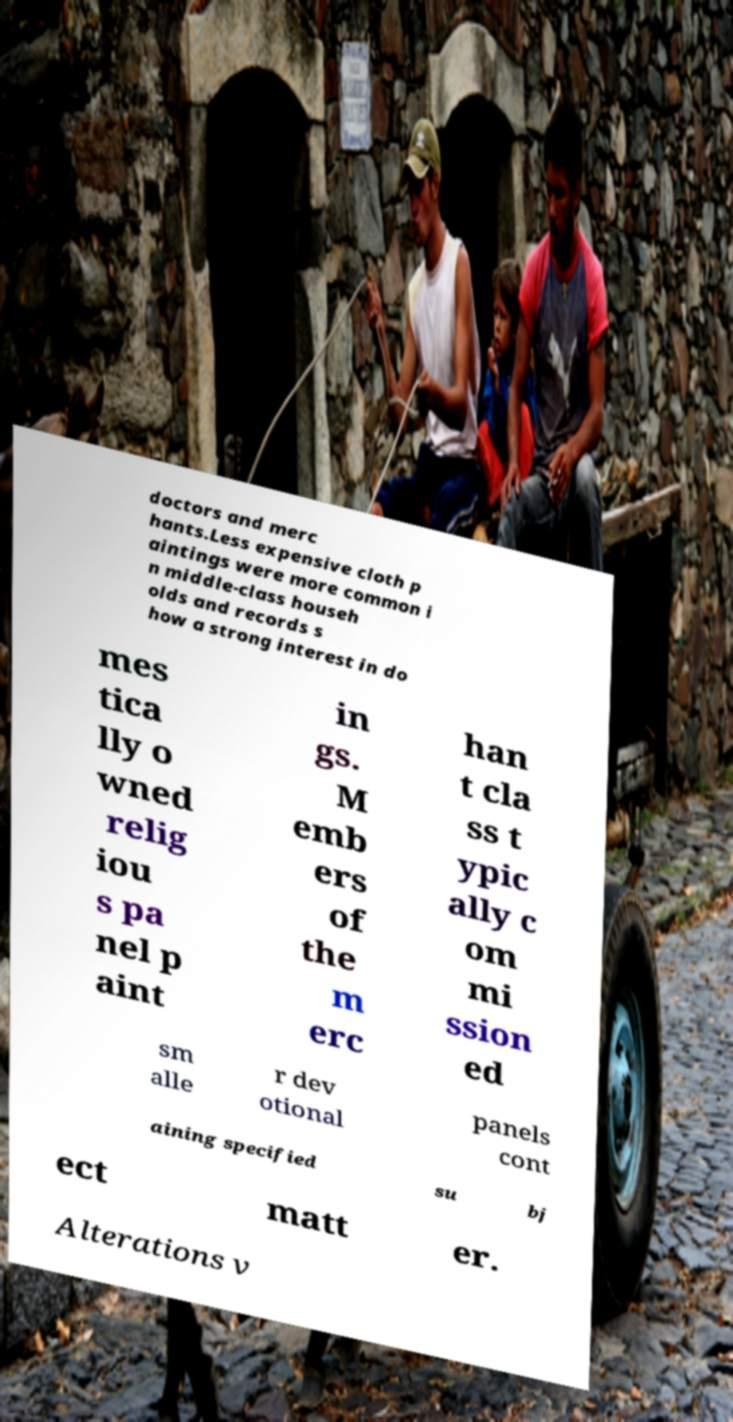Can you read and provide the text displayed in the image?This photo seems to have some interesting text. Can you extract and type it out for me? doctors and merc hants.Less expensive cloth p aintings were more common i n middle-class househ olds and records s how a strong interest in do mes tica lly o wned relig iou s pa nel p aint in gs. M emb ers of the m erc han t cla ss t ypic ally c om mi ssion ed sm alle r dev otional panels cont aining specified su bj ect matt er. Alterations v 